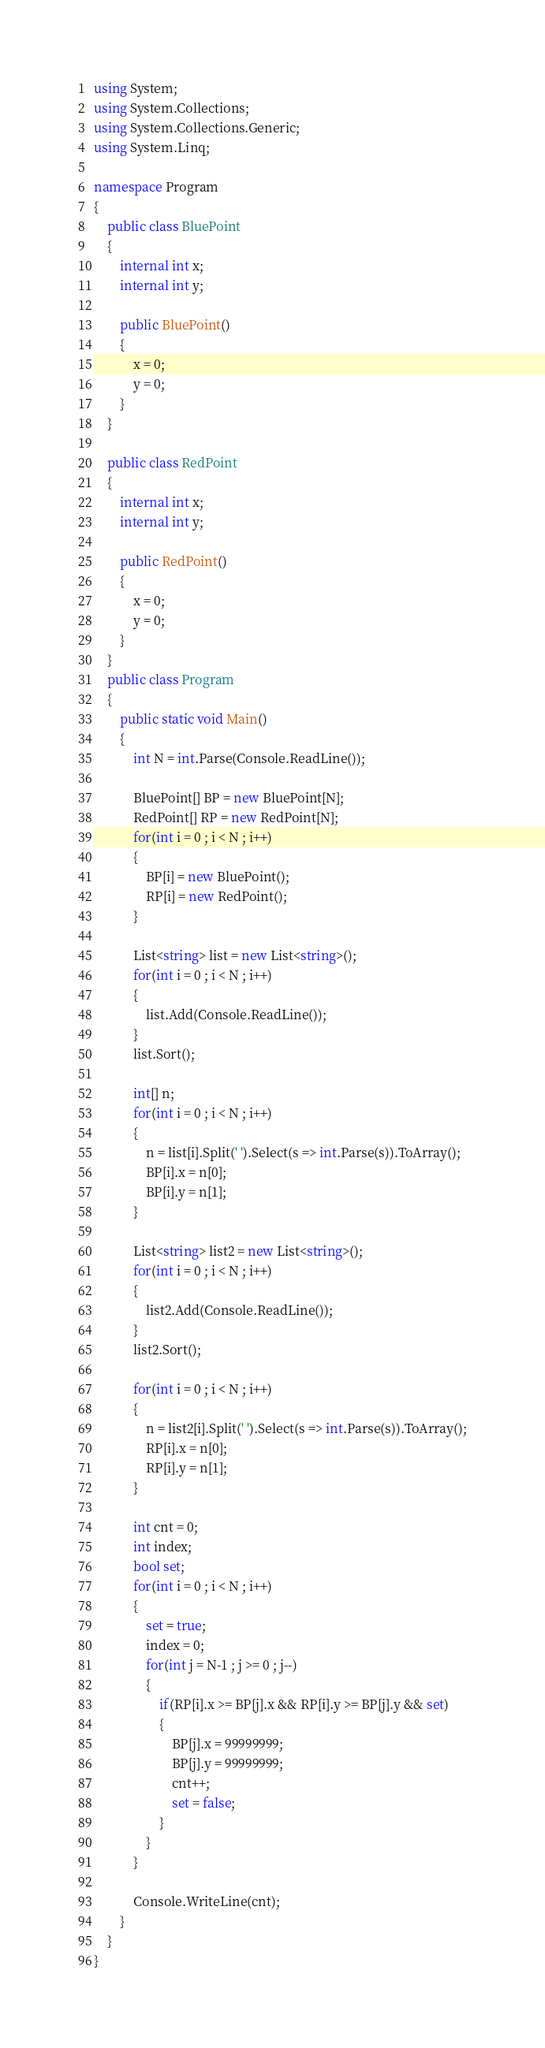Convert code to text. <code><loc_0><loc_0><loc_500><loc_500><_C#_>using System;
using System.Collections;
using System.Collections.Generic;
using System.Linq;

namespace Program
{
    public class BluePoint
    {
        internal int x;
        internal int y;
        
        public BluePoint()
        {
            x = 0;
            y = 0;
        }
    }
    
    public class RedPoint
    {
        internal int x;
        internal int y;
        
        public RedPoint()
        {
            x = 0;
            y = 0;
        }
    }
    public class Program
    {	
        public static void Main()
    	{
            int N = int.Parse(Console.ReadLine());

            BluePoint[] BP = new BluePoint[N];
            RedPoint[] RP = new RedPoint[N];
            for(int i = 0 ; i < N ; i++)
            {
                BP[i] = new BluePoint();
                RP[i] = new RedPoint();
            }
            
            List<string> list = new List<string>();
            for(int i = 0 ; i < N ; i++)
            {
                list.Add(Console.ReadLine());
            }
            list.Sort();
            
            int[] n; 
            for(int i = 0 ; i < N ; i++)
            {
                n = list[i].Split(' ').Select(s => int.Parse(s)).ToArray();
                BP[i].x = n[0];
                BP[i].y = n[1];
            }
            
            List<string> list2 = new List<string>();
            for(int i = 0 ; i < N ; i++)
            {
                list2.Add(Console.ReadLine());
            }
            list2.Sort();
            
            for(int i = 0 ; i < N ; i++)
            {
                n = list2[i].Split(' ').Select(s => int.Parse(s)).ToArray();
                RP[i].x = n[0];
                RP[i].y = n[1];
            }
            
            int cnt = 0;
            int index;
            bool set;
            for(int i = 0 ; i < N ; i++)
            {
                set = true; 
                index = 0;
                for(int j = N-1 ; j >= 0 ; j--)
                {
                    if(RP[i].x >= BP[j].x && RP[i].y >= BP[j].y && set)
                    {
                        BP[j].x = 99999999;
                        BP[j].y = 99999999;
                        cnt++;
                        set = false;
                    }
                } 
            }
            
            Console.WriteLine(cnt);
    	}
    }
}</code> 